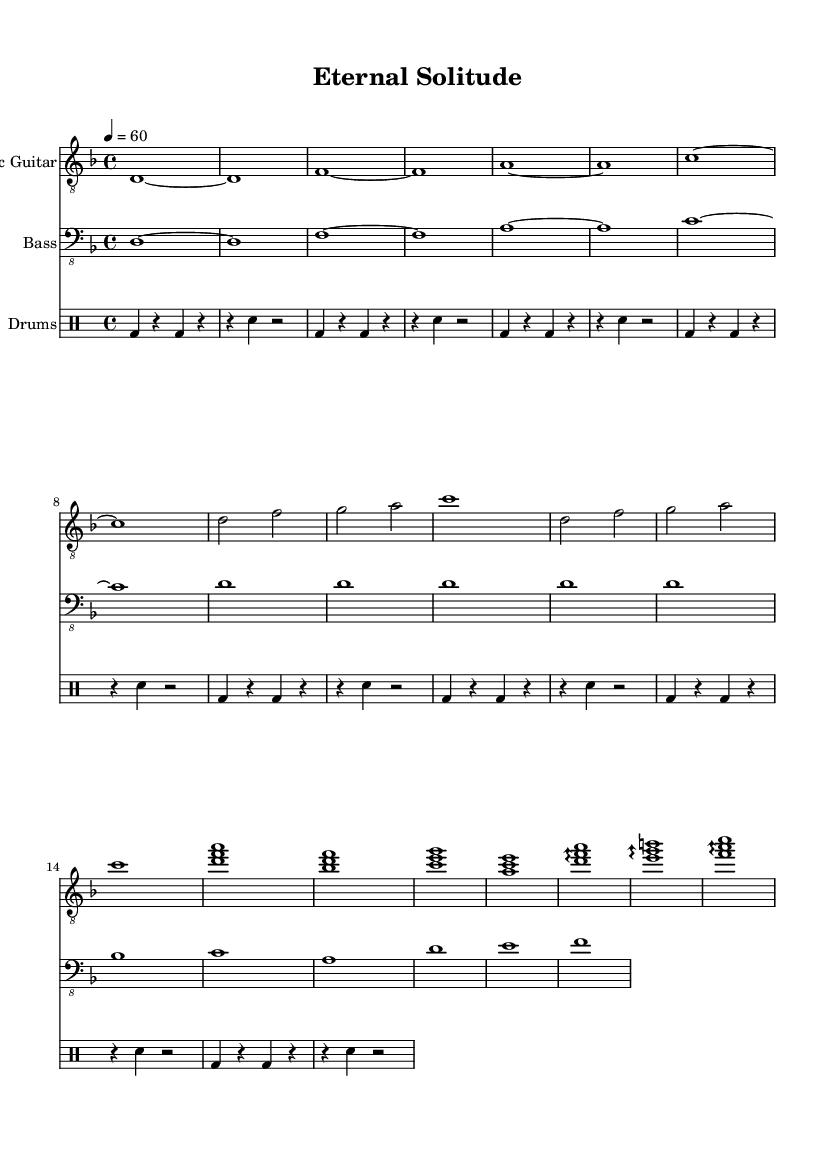What is the key signature of this music? The key signature is indicated at the beginning of the piece. The sheet music shows one flat, which means it is in D minor.
Answer: D minor What is the time signature of this piece? The time signature is shown at the beginning of the score. The fraction indicates four beats per measure, denoted as 4/4.
Answer: 4/4 What is the tempo marking of this music? The tempo marking is found near the top of the score, denoted as "4 = 60", indicating that there should be 60 beats per minute.
Answer: 60 How many measures are in the main riff section? The main riff section has a total of 8 measures, as counted in the electric guitar and bass parts.
Answer: 8 What instrument plays the bridge section's arpeggios? The bridge section features arpeggios played on the electric guitar, as indicated by the notation in the electric guitar staff.
Answer: Electric Guitar How many different sections are labeled in this music? The sections indicated in the sheet are the main riff, verse, chorus, and bridge, totaling four distinct sections in the piece.
Answer: 4 What type of drum pattern is predominantly used in this piece? The drum part primarily features a bass drum and snare pattern, characterized by alternating bass and snare hits throughout the sections, typical of doom metal.
Answer: Bass and snare 